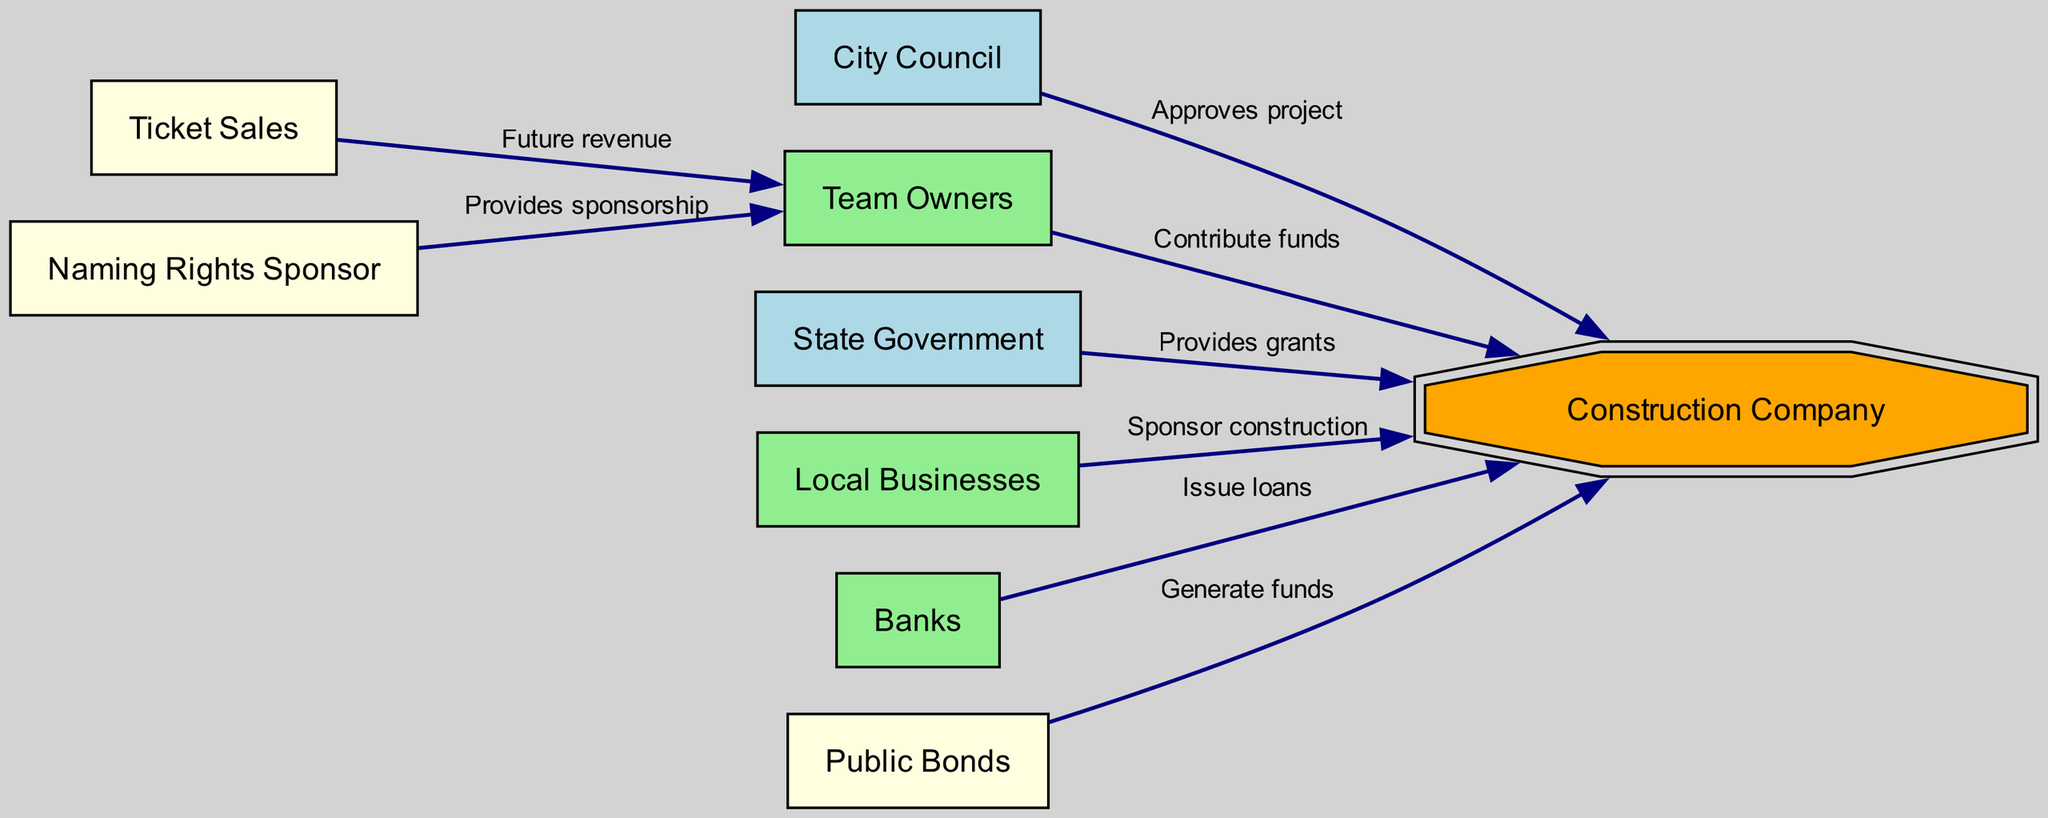What is the total number of nodes in the diagram? The diagram contains a list of nodes: City Council, Team Owners, State Government, Local Businesses, Banks, Construction Company, Public Bonds, Ticket Sales, and Naming Rights Sponsor. Counting these gives a total of 9 nodes.
Answer: 9 Which entity provides grants to the Construction Company? The edge labeled "Provides grants" connects the State Government to the Construction Company, indicating that the State Government provides grants.
Answer: State Government How many entities contribute funds to the Construction Company? The diagram shows four different entities that contribute funds to the Construction Company: Team Owners, State Government, Local Businesses, and Banks. This totals to four contributors.
Answer: 4 What is the relationship between the Team Owners and Ticket Sales? The edge labeled "Future revenue" shows a directional flow from Ticket Sales to Team Owners, meaning Team Owners benefit from Ticket Sales revenue in the future.
Answer: Future revenue Which entities are designated in light green? The Team Owners, Local Businesses, and Banks are all shown in light green color in the diagram, indicating their roles as funding sources.
Answer: Team Owners, Local Businesses, Banks Which entity is the target for funds generated by Public Bonds? According to the edge labeled "Generate funds," Public Bonds direct their funds towards the Construction Company, establishing a funding link to it.
Answer: Construction Company What is the primary function of the Construction Company in this diagram? The Construction Company serves as the recipient of various funding streams and approvals from multiple entities, acting as the central hub for the funding flow in the stadium project.
Answer: Central hub for funding How many funding sources directly interact with the Construction Company? The Construction Company receives funds and approvals from five sources: City Council, Team Owners, State Government, Local Businesses, and Banks, indicating direct interaction.
Answer: 5 What type of sponsorship do the Naming Rights Sponsor provide? The edge labeled "Provides sponsorship" designates that the Naming Rights Sponsor offers financial support to the Team Owners, highlighting their sponsorship role in the project.
Answer: Provides sponsorship 